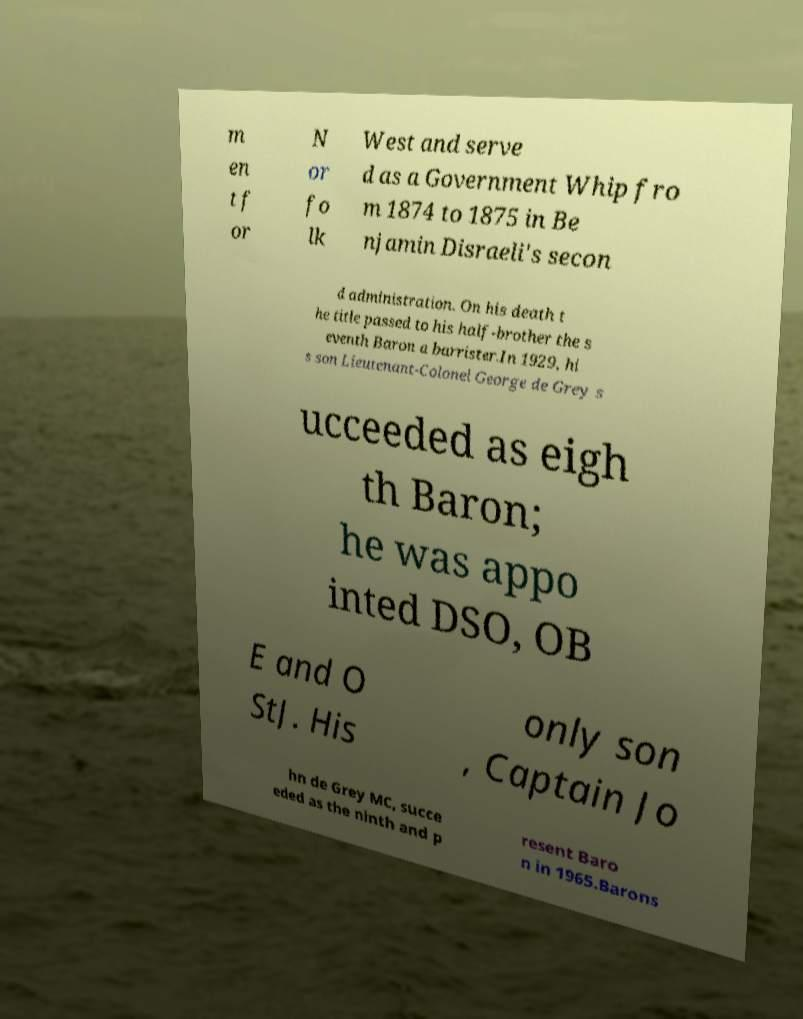Could you extract and type out the text from this image? m en t f or N or fo lk West and serve d as a Government Whip fro m 1874 to 1875 in Be njamin Disraeli's secon d administration. On his death t he title passed to his half-brother the s eventh Baron a barrister.In 1929, hi s son Lieutenant-Colonel George de Grey s ucceeded as eigh th Baron; he was appo inted DSO, OB E and O StJ. His only son , Captain Jo hn de Grey MC, succe eded as the ninth and p resent Baro n in 1965.Barons 